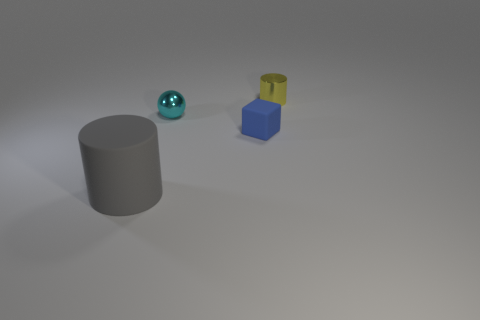Imagine if this were a scene from a story. What kind of narrative could you infer from the arrangement of these objects? The arrangement of the objects could represent a moment of quiet tension. The grey cylinder could symbolize a stoic character, the bright metal sphere a mysterious artifact, and the stacked blue and yellow blocks a constructed totem or marker. The cool, diffuse lighting suggests a calm but potentially foreboding atmosphere, as if the objects are on the verge of an eventful discovery or an encounter. 